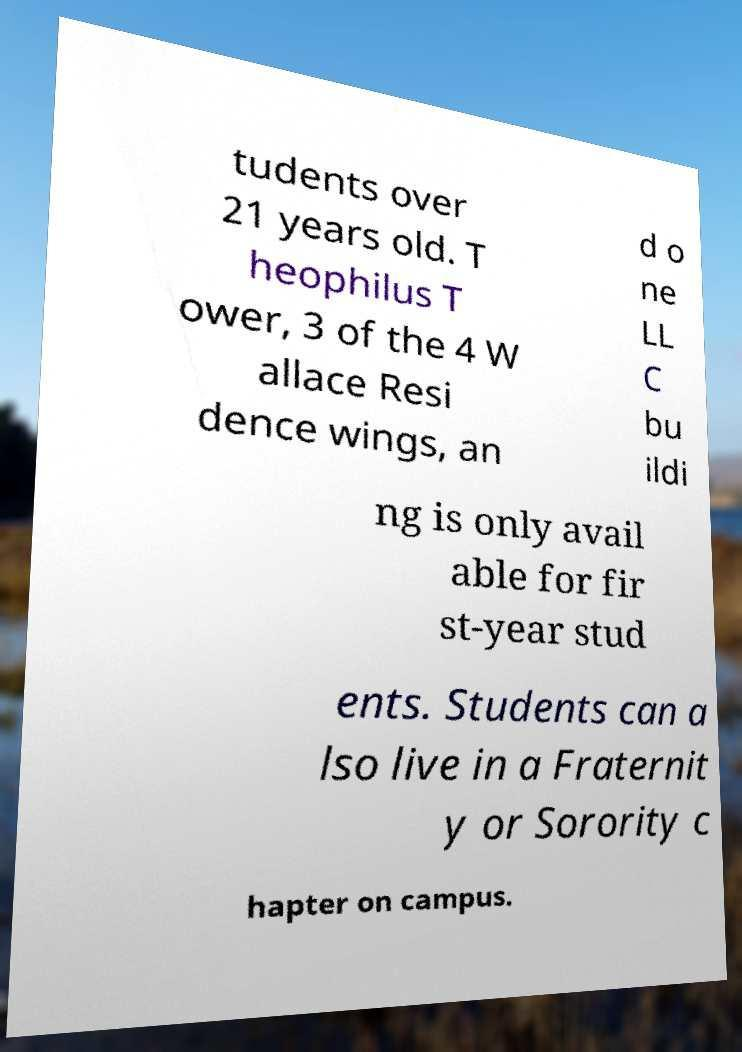Could you assist in decoding the text presented in this image and type it out clearly? tudents over 21 years old. T heophilus T ower, 3 of the 4 W allace Resi dence wings, an d o ne LL C bu ildi ng is only avail able for fir st-year stud ents. Students can a lso live in a Fraternit y or Sorority c hapter on campus. 